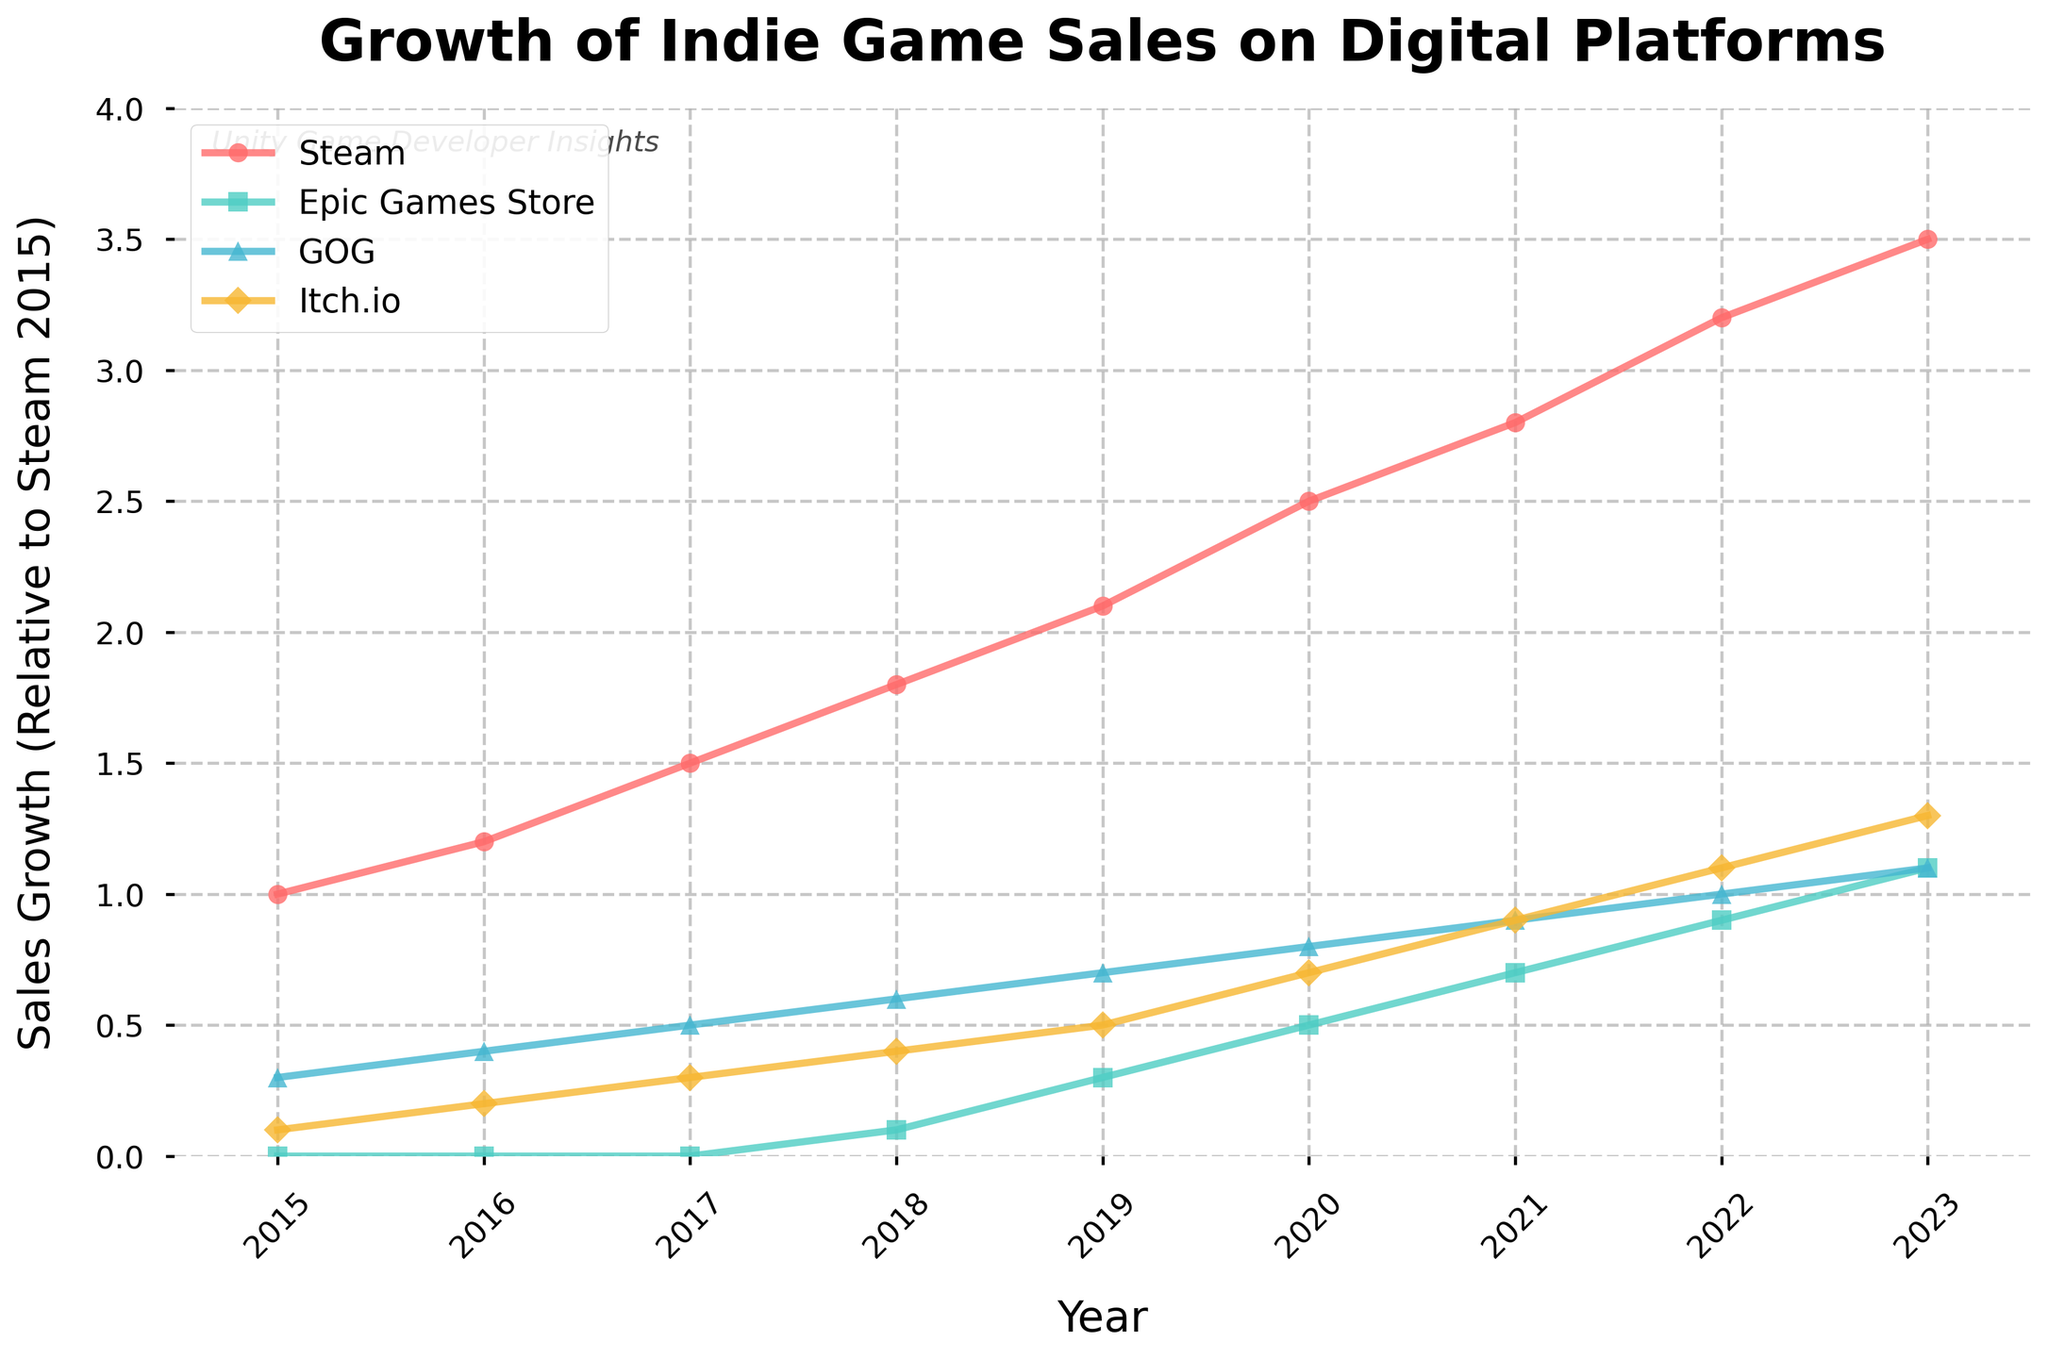What platform showed the highest sales growth in 2023? The chart shows different sales growth lines for various platforms, and the topmost line in 2023 is the indicator of the platform with the highest growth. Checking the chart, Steam's line is the highest in 2023.
Answer: Steam Which platform had its first year of recorded sales growth in 2018? By examining the plot lines for all platforms, we see that Epic Games Store starts its growth from 2018.
Answer: Epic Games Store Between which two years did Itch.io see the largest increase in sales growth? By comparing the slopes of Itch.io's line between consecutive years, the steepest increase is between 2021 and 2022.
Answer: 2021 and 2022 What is the difference in sales growth between Steam and GOG in 2020? Locate the exact points of 2020 for both Steam and GOG. Steam is at 2.5 while GOG is at 0.8. The difference is 2.5 - 0.8.
Answer: 1.7 What was the relative sales growth value for GOG in 2017? By tracing the GOG line in the chart to the 2017 mark on the x-axis, we identify the value as 0.5.
Answer: 0.5 Which platform had the closest sales growth to Steam in 2023? Comparing the heights of all platforms' lines near 2023, Epic Games Store with the value of 1.1 is the closest to Steam’s 3.5.
Answer: Epic Games Store What is the average sales growth for Itch.io from 2015 to 2023? By adding Itch.io's values for each year and dividing by 9: (0.1 + 0.2 + 0.3 + 0.4 + 0.5 + 0.7 + 0.9 + 1.1 + 1.3)/9 = 5.5/9.
Answer: 0.61 Which year did Steam sales growth surpass the value of 2.0? Examining the trend line for Steam, it crosses the 2.0 mark between 2018 and 2019. Thus, the first full year above 2.0 is 2019.
Answer: 2019 